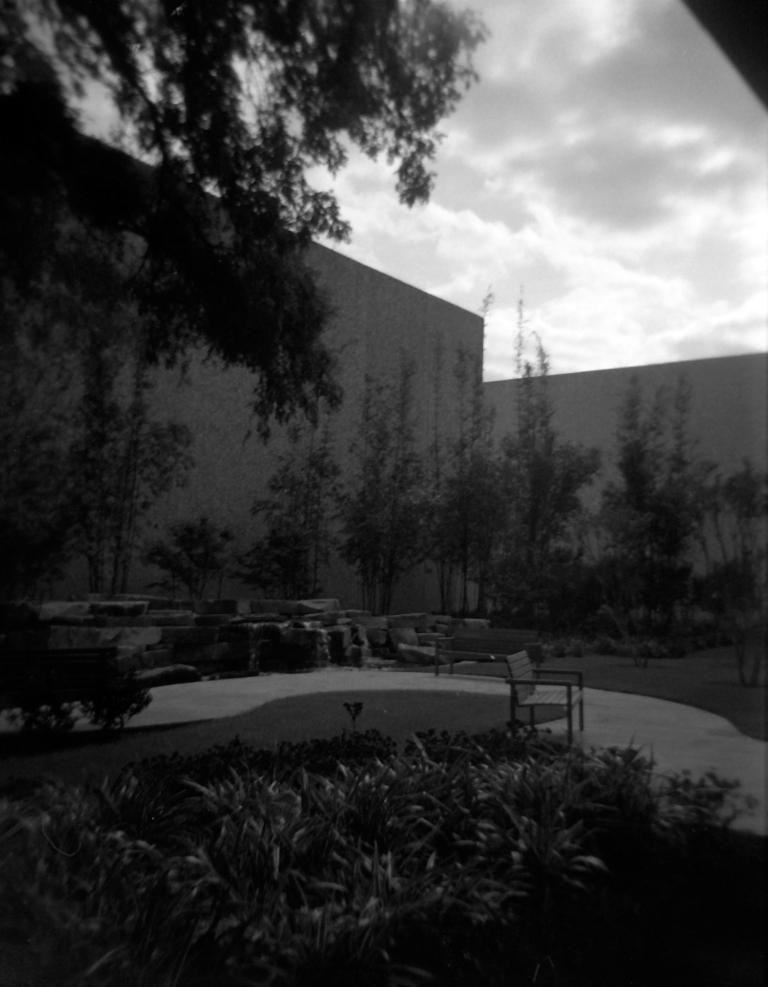What type of natural elements can be seen in the image? There are trees and plants in the image. What type of man-made structures are present in the image? There are walls in the image. What is visible in the background of the image? The sky is visible in the background of the image. What is the color scheme of the image? The image is black and white in color. Is there a group of people committing a crime in the image? There is no group of people or any indication of a crime in the image; it features trees, plants, walls, and a black and white color scheme. What is the elevation of the plants in the image? The elevation of the plants cannot be determined from the image, as there is no reference point for comparison. 